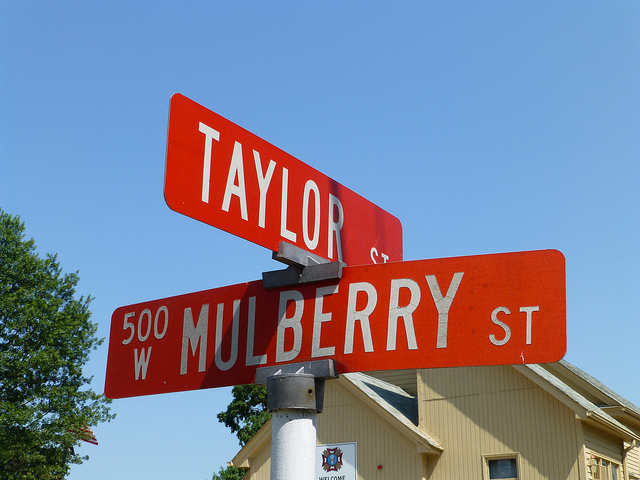<image>What city is this intersection in? It is unknown which city the intersection is in. It can be any city such as London, New York, Boston, Detroit, Mulberry, Chicago, Portland, or Evansville. What city is this intersection in? I don't know what city this intersection is in. It can be any of ['london', 'new york', 'boston', 'detroit', 'mulberry', 'chicago', 'portland', 'evansville']. 